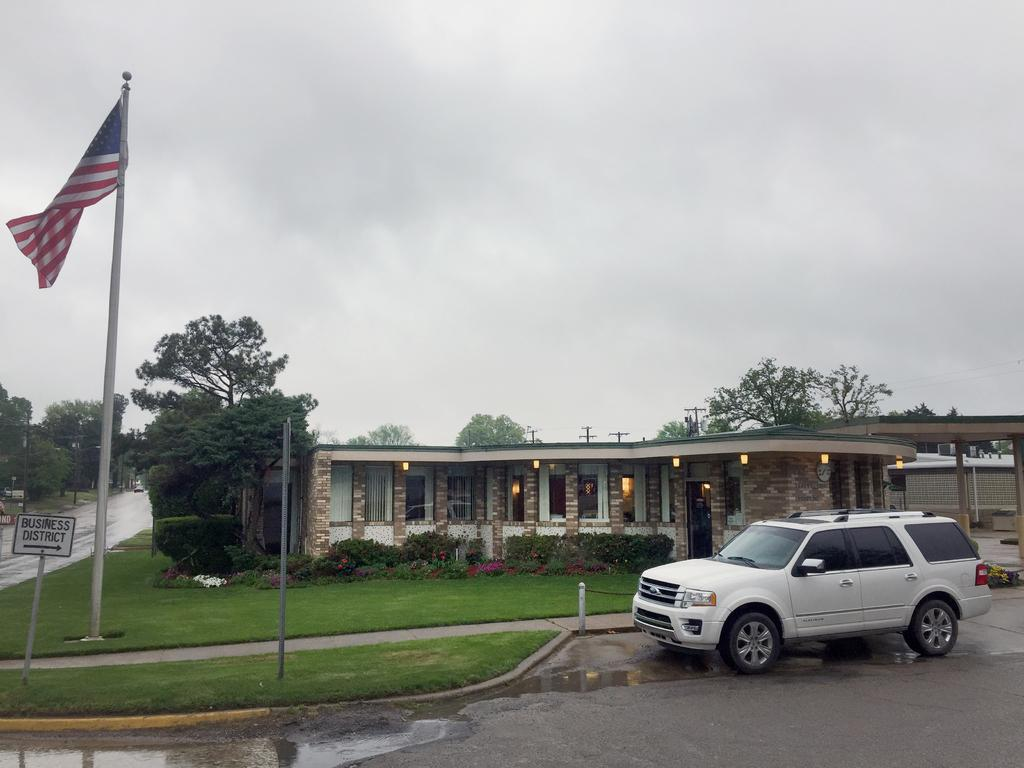What is located in the foreground of the image? There is a car on the road and a flag in the foreground of the image. What else can be seen in the foreground of the image? There are sign boards on the grass in the foreground of the image. What is visible in the background of the image? There is a building, plants, trees, poles, a road, and the sky visible in the background of the image. What note is being played by the trees in the background of the image? There are no musical notes or instruments present in the image, so it is not possible to determine if any notes are being played. How many units of death can be seen in the image? There is no reference to death or any units associated with it in the image. 